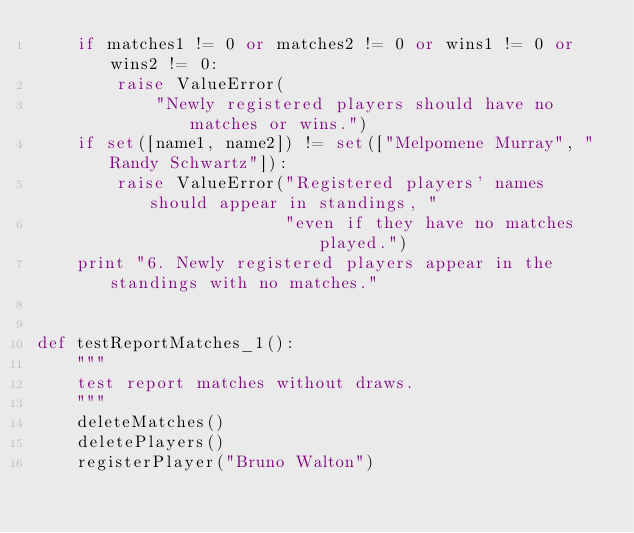Convert code to text. <code><loc_0><loc_0><loc_500><loc_500><_Python_>    if matches1 != 0 or matches2 != 0 or wins1 != 0 or wins2 != 0:
        raise ValueError(
            "Newly registered players should have no matches or wins.")
    if set([name1, name2]) != set(["Melpomene Murray", "Randy Schwartz"]):
        raise ValueError("Registered players' names should appear in standings, "
                         "even if they have no matches played.")
    print "6. Newly registered players appear in the standings with no matches."


def testReportMatches_1():
    """
    test report matches without draws.
    """
    deleteMatches()
    deletePlayers()
    registerPlayer("Bruno Walton")</code> 